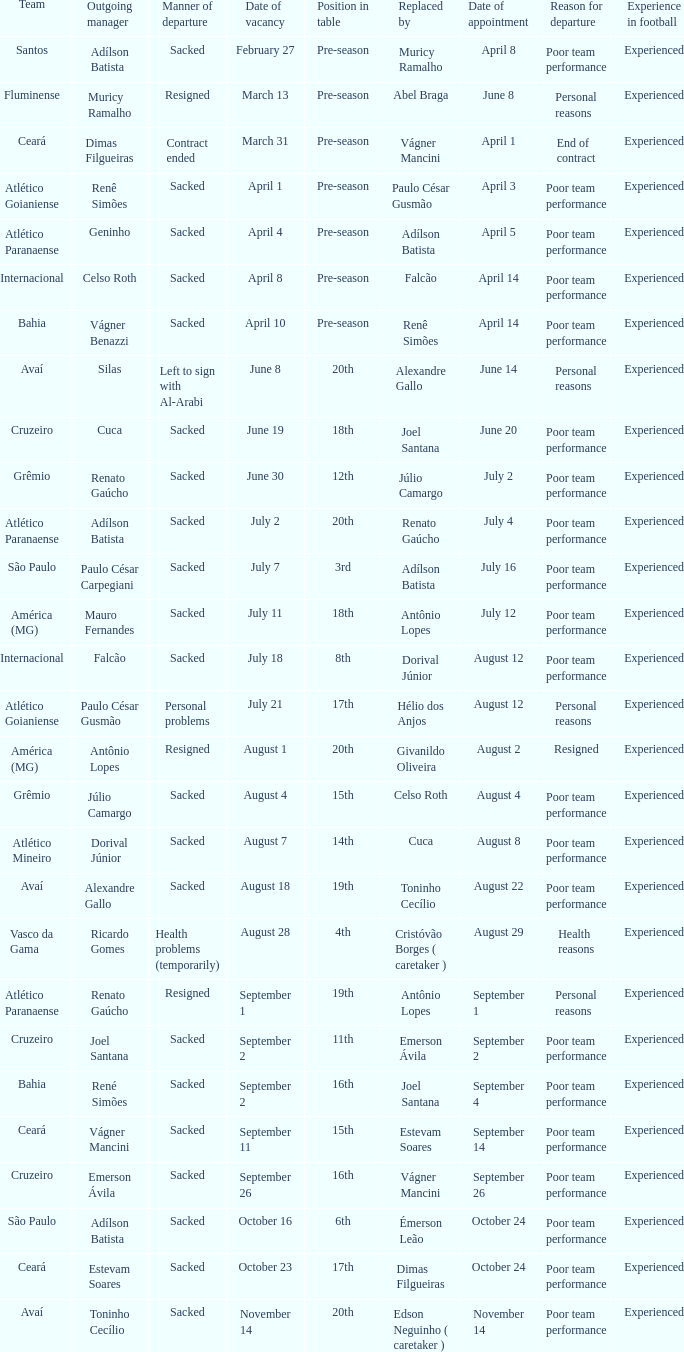Who was replaced as manager on June 20? Cuca. 